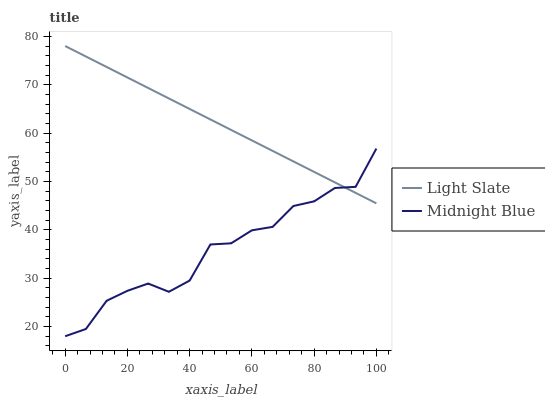Does Midnight Blue have the minimum area under the curve?
Answer yes or no. Yes. Does Light Slate have the maximum area under the curve?
Answer yes or no. Yes. Does Midnight Blue have the maximum area under the curve?
Answer yes or no. No. Is Light Slate the smoothest?
Answer yes or no. Yes. Is Midnight Blue the roughest?
Answer yes or no. Yes. Is Midnight Blue the smoothest?
Answer yes or no. No. Does Midnight Blue have the lowest value?
Answer yes or no. Yes. Does Light Slate have the highest value?
Answer yes or no. Yes. Does Midnight Blue have the highest value?
Answer yes or no. No. Does Midnight Blue intersect Light Slate?
Answer yes or no. Yes. Is Midnight Blue less than Light Slate?
Answer yes or no. No. Is Midnight Blue greater than Light Slate?
Answer yes or no. No. 